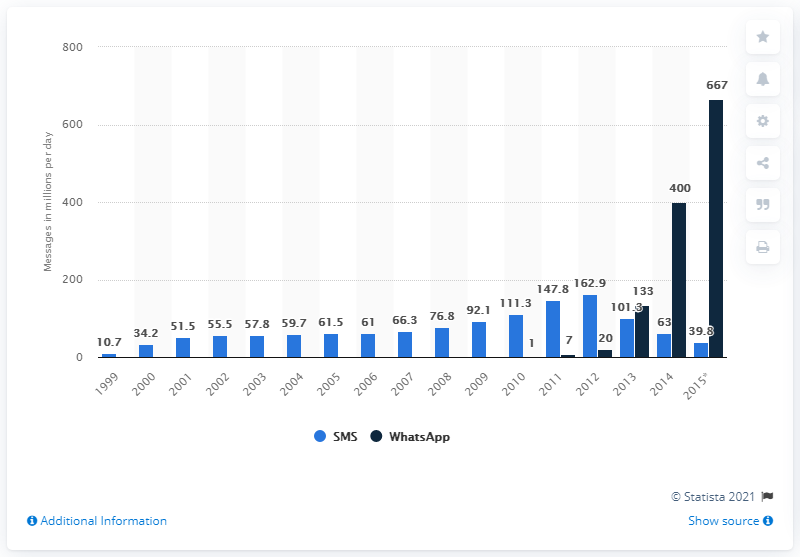Highlight a few significant elements in this photo. In 2014, an estimated 400 million WhatsApp messages were sent in Germany. In 2014, approximately 63 million SMS messages and 400 million WhatsApp messages were sent in Germany. 